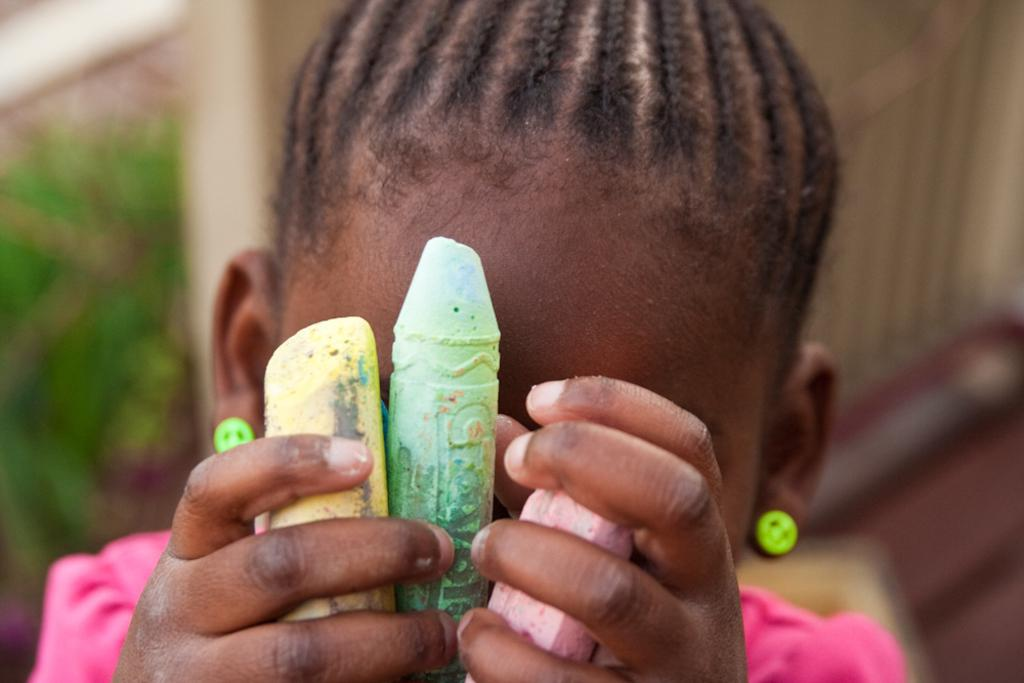What is the main subject of the image? There is a baby in the image. What is the baby wearing? The baby is wearing a pink dress. What is the baby holding in the image? The baby is holding objects that resemble chalks. Can you describe the background of the image? The background of the image is blurred. What type of skirt is the baby wearing in the image? The baby is not wearing a skirt; they are wearing a pink dress. Are there any visible socks on the baby in the image? There is no mention of socks in the provided facts, and none are visible in the image. 